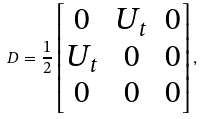<formula> <loc_0><loc_0><loc_500><loc_500>D = \frac { 1 } { 2 } \begin{bmatrix} 0 & U _ { t } & 0 \\ U _ { t } & 0 & 0 \\ 0 & 0 & 0 \end{bmatrix} ,</formula> 